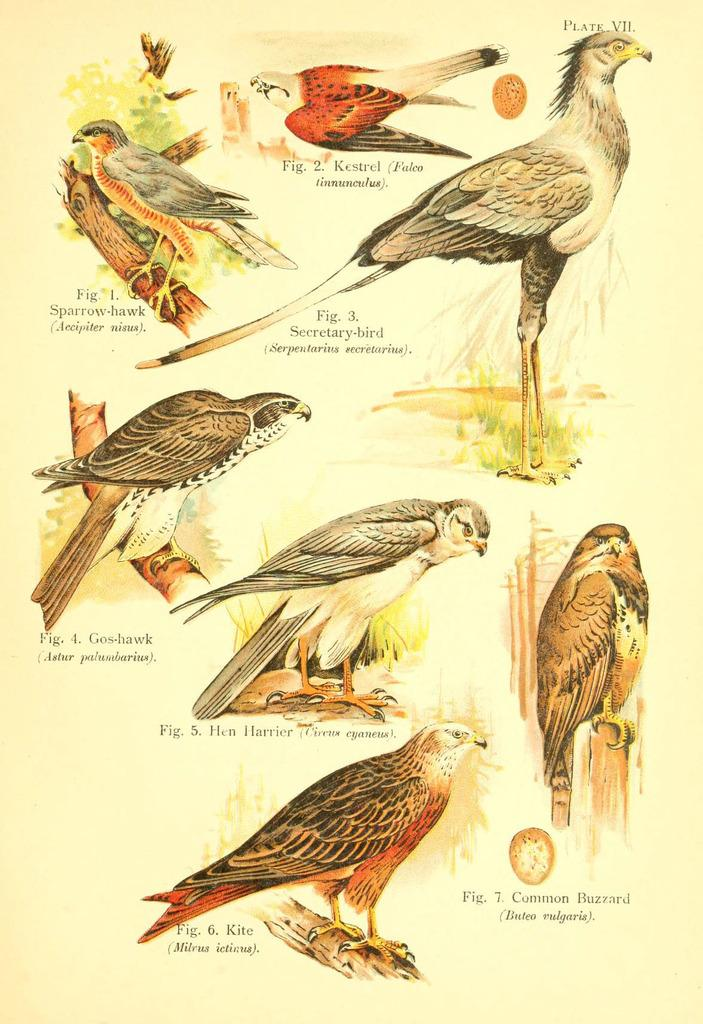What is present on the paper in the image? The paper contains images of birds. Are there any other elements on the paper besides the images of birds? Yes, there is text on the paper. What type of wax is used to create the images of birds on the paper? There is no wax mentioned or visible in the image; the images of birds are likely created using ink or another printing method. 